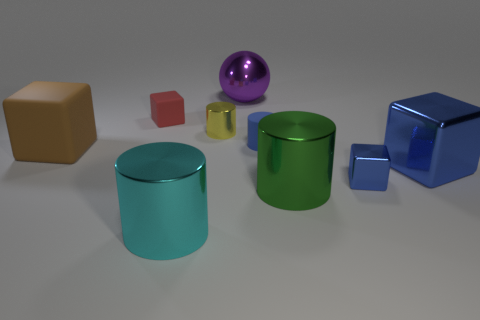What number of other things are there of the same material as the big blue cube
Provide a succinct answer. 5. Does the brown rubber object that is on the left side of the blue rubber thing have the same size as the large blue thing?
Keep it short and to the point. Yes. How many objects are either small metal objects that are on the right side of the blue rubber cylinder or small matte cylinders?
Make the answer very short. 2. Is there a blue object that has the same size as the red thing?
Make the answer very short. Yes. What material is the red thing that is the same size as the blue rubber cylinder?
Your answer should be very brief. Rubber. There is a big shiny object that is both behind the small blue cube and in front of the purple metallic thing; what is its shape?
Offer a terse response. Cube. What color is the rubber object that is behind the blue matte object?
Provide a short and direct response. Red. How big is the metal thing that is on the right side of the small metal cylinder and behind the blue matte object?
Your answer should be compact. Large. Is the material of the small red block the same as the small cylinder that is to the left of the tiny blue cylinder?
Provide a short and direct response. No. What number of brown matte things are the same shape as the green metallic object?
Make the answer very short. 0. 